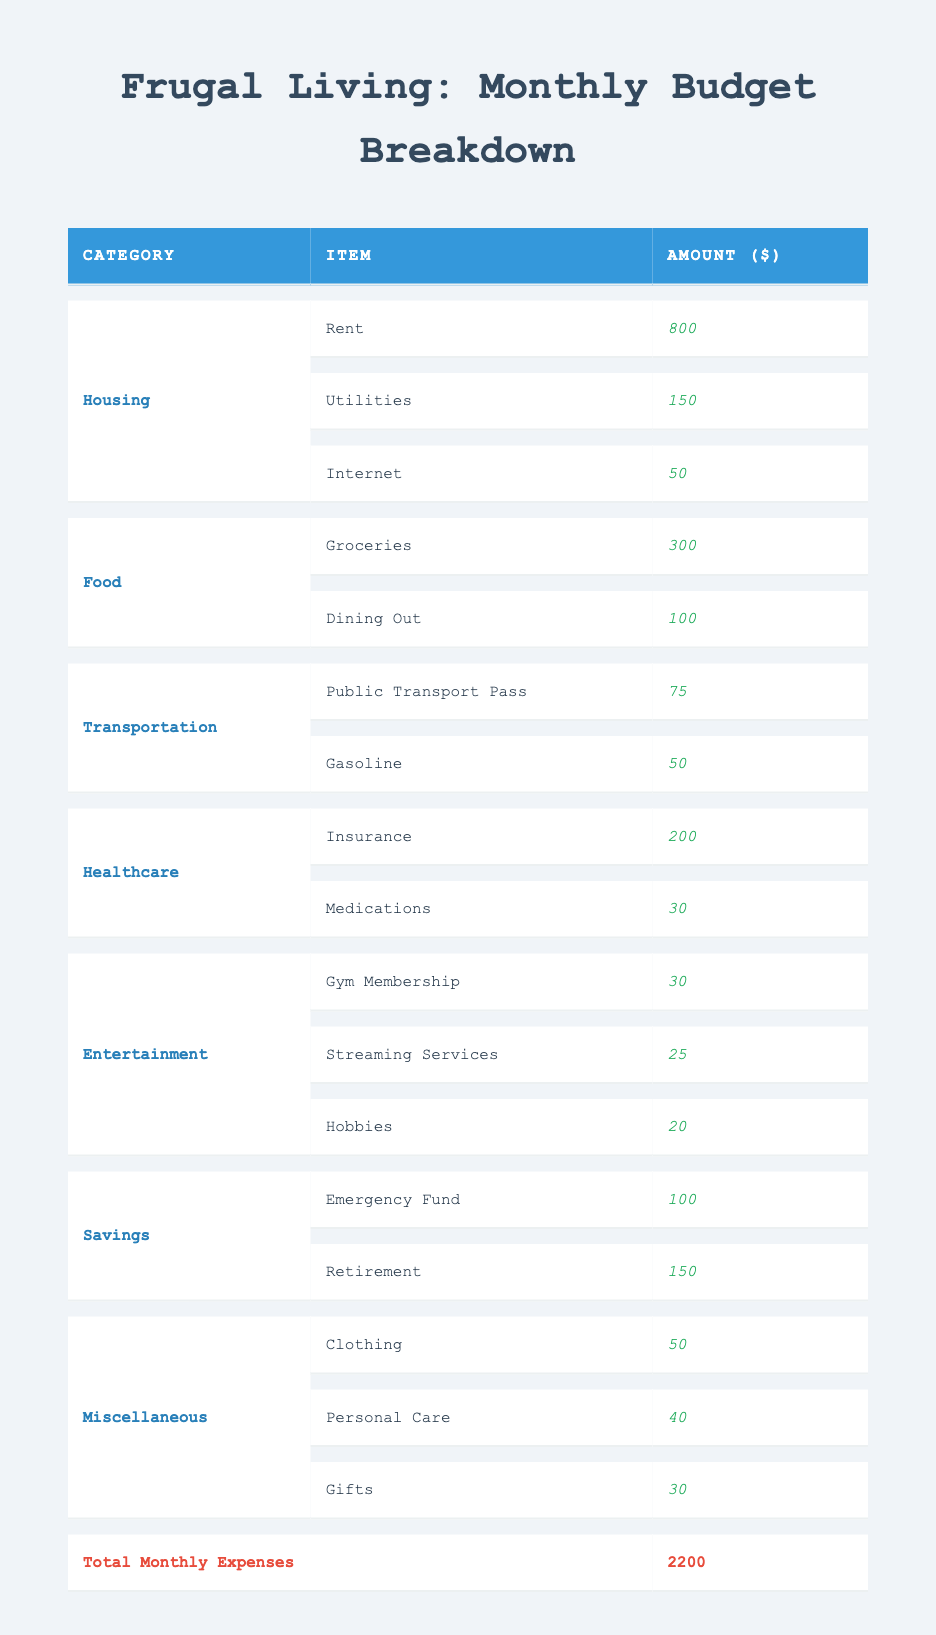What is the total amount spent on housing? The table shows three amounts under the housing category: rent ($800), utilities ($150), and internet ($50). To find the total, we add these amounts together: 800 + 150 + 50 = 1000.
Answer: 1000 How much is spent on food compared to transportation? The total food expenses consist of groceries ($300) and dining out ($100), totaling 400. Transportation expenses include a public transport pass ($75) and gasoline ($50), totaling 125. 400 - 125 = 275 indicates that food expenses are 275 more than transportation expenses.
Answer: 275 Is the amount spent on healthcare greater than the amount spent on entertainment? Healthcare costs are insurance ($200) and medications ($30), giving a total of 230. Entertainment costs are gym membership ($30), streaming services ($25), and hobbies ($20), totaling 75. Since 230 > 75, the healthcare amount is greater.
Answer: Yes What is the average monthly expense across all categories? First, we calculate the total monthly expenses from each category: housing (1000), food (400), transportation (125), healthcare (230), entertainment (75), savings (250), and miscellaneous (120). The sum is 2200. There are 7 categories, so we compute the average by dividing the total by the number of categories: 2200 / 7 ≈ 314.29.
Answer: 314.29 What percentage of the total expenses is allocated to food? The food expenses total 400, while total expenses are 2200. To find the percentage, we divide the food expenses by the total and multiply by 100: (400 / 2200) * 100 ≈ 18.18%.
Answer: 18.18% What is the combined expense for savings and miscellaneous categories? Savings amount to 250 (emergency fund 100 + retirement 150) and miscellaneous costs 120 (clothing 50 + personal care 40 + gifts 30). Combining both, 250 + 120 = 370.
Answer: 370 Are the expenses for dining out higher than the total amount spent on personal care and gifts? Dining out costs 100, personal care is 40 and gifts are 30, giving a total of 70. Since 100 > 70, dining out expenses exceed those for personal care and gifts.
Answer: Yes What is the difference between the total amount spent on transportation and healthcare? Transportation totals 125 (public transport pass 75 + gasoline 50) while healthcare totals 230 (insurance 200 + medications 30). The difference is 230 - 125 = 105.
Answer: 105 How much more is spent on rent compared to the total entertainment expenses? Rent costs 800, while entertainment is 75 (gym membership 30 + streaming services 25 + hobbies 20). The difference is 800 - 75 = 725, indicating that rent is 725 more than total entertainment expenses.
Answer: 725 What is the total for all utilities and monthly healthcare costs combined? Utilities cost 150, and healthcare costs 230, so we sum these amounts: 150 + 230 = 380.
Answer: 380 